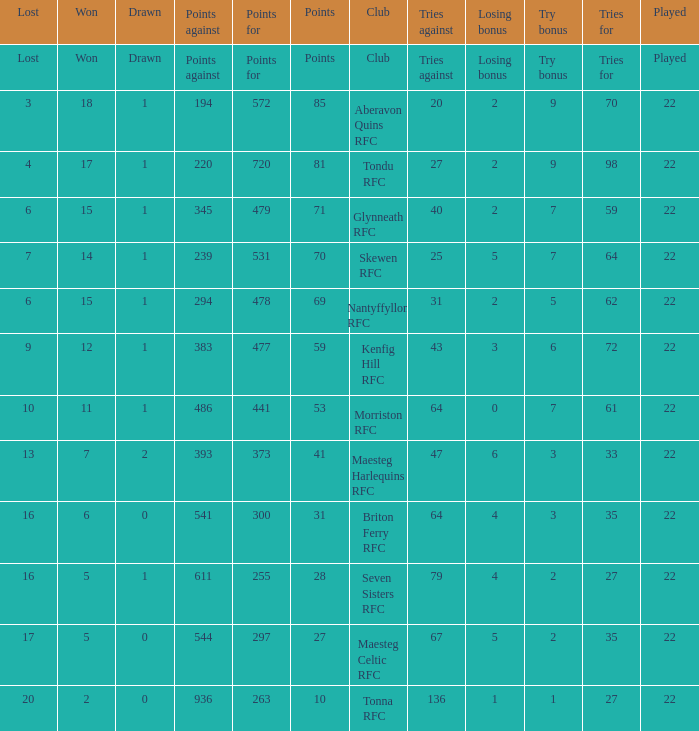How many tries against got the club with 62 tries for? 31.0. 